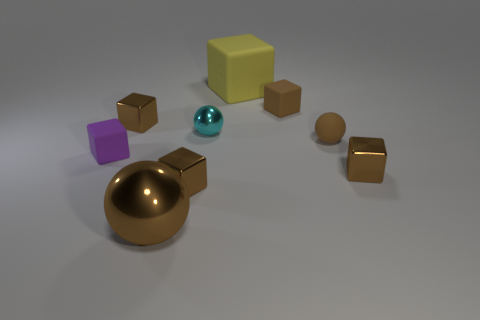Subtract all brown cubes. How many were subtracted if there are1brown cubes left? 3 Subtract all blue spheres. How many brown cubes are left? 4 Subtract 1 cubes. How many cubes are left? 5 Subtract all brown rubber blocks. How many blocks are left? 5 Subtract all purple blocks. How many blocks are left? 5 Subtract all green cubes. Subtract all brown cylinders. How many cubes are left? 6 Subtract all blocks. How many objects are left? 3 Add 5 small purple objects. How many small purple objects exist? 6 Subtract 1 cyan balls. How many objects are left? 8 Subtract all purple cubes. Subtract all metallic cubes. How many objects are left? 5 